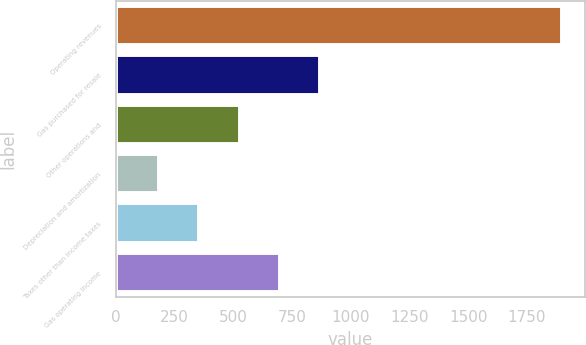Convert chart to OTSL. <chart><loc_0><loc_0><loc_500><loc_500><bar_chart><fcel>Operating revenues<fcel>Gas purchased for resale<fcel>Other operations and<fcel>Depreciation and amortization<fcel>Taxes other than income taxes<fcel>Gas operating income<nl><fcel>1901<fcel>871.4<fcel>528.2<fcel>185<fcel>356.6<fcel>699.8<nl></chart> 